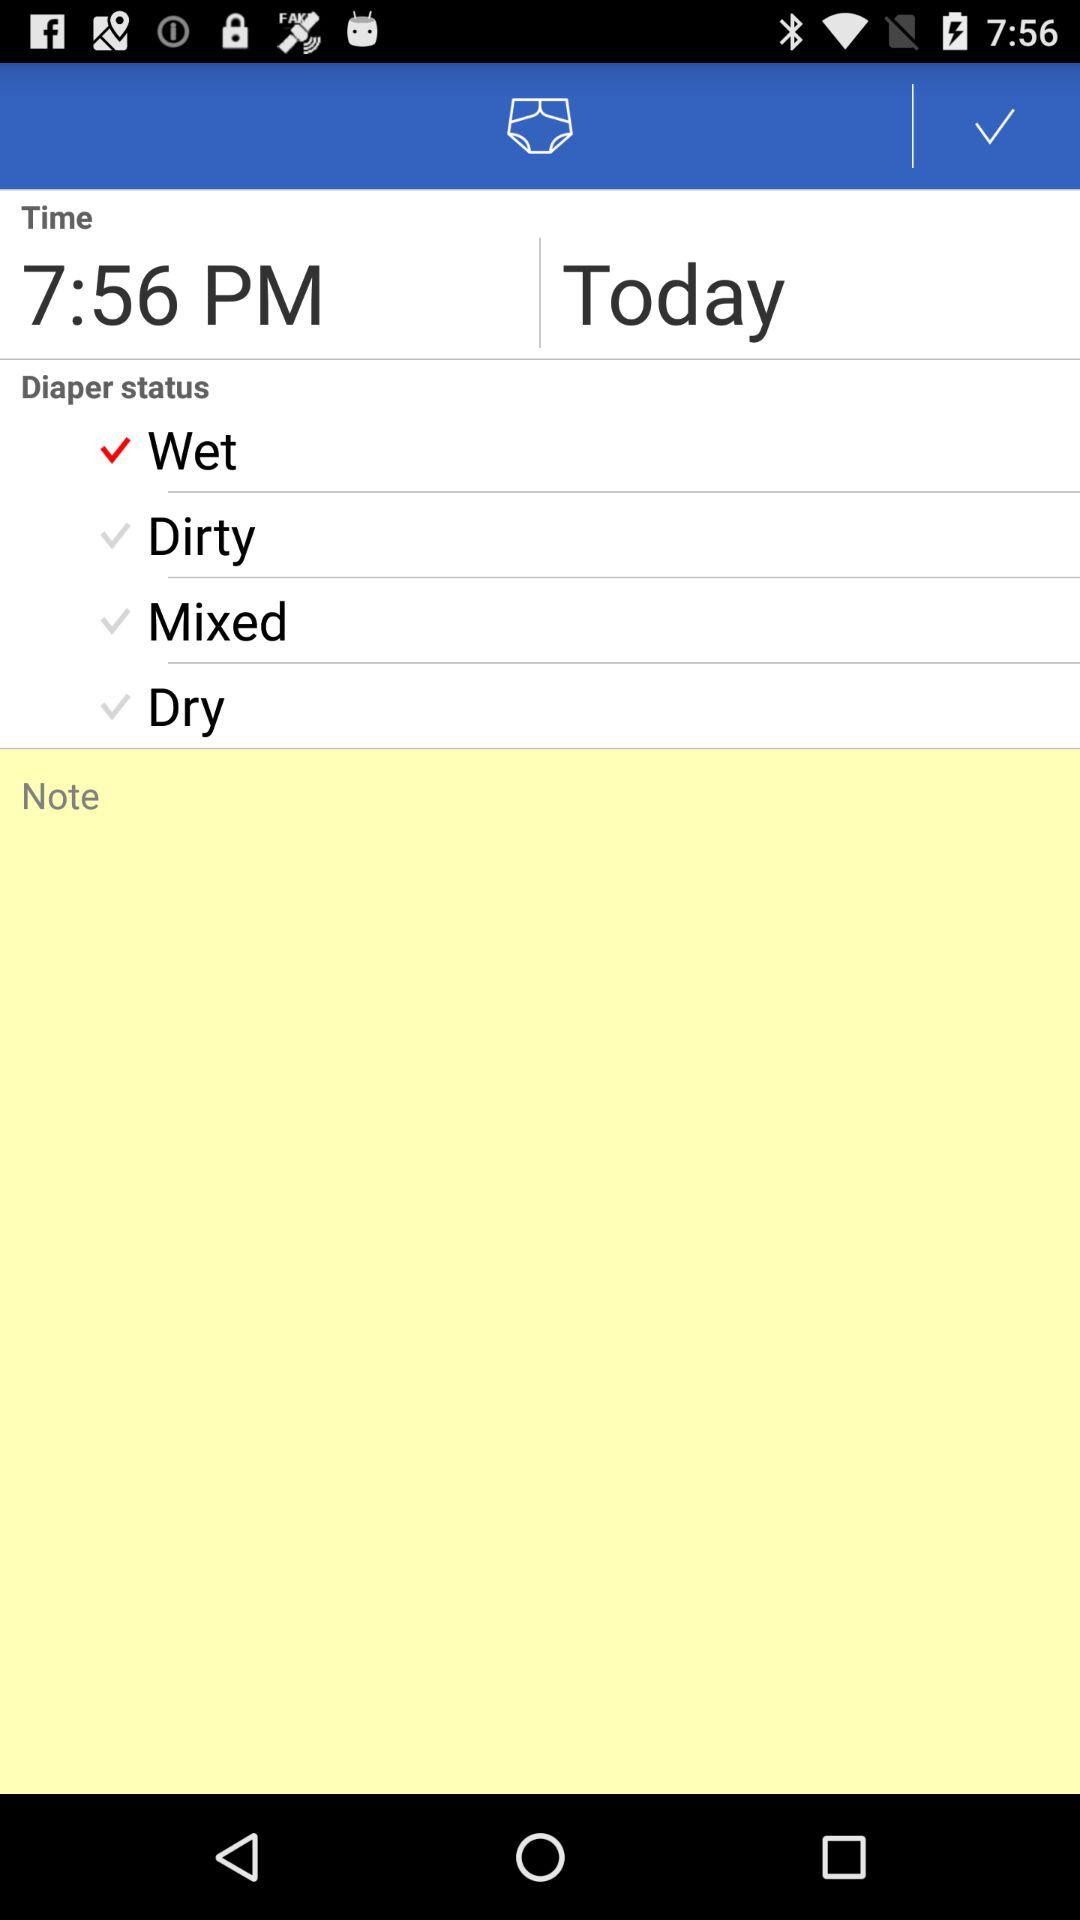What is the given time? The given time is 7:56 p.m. 